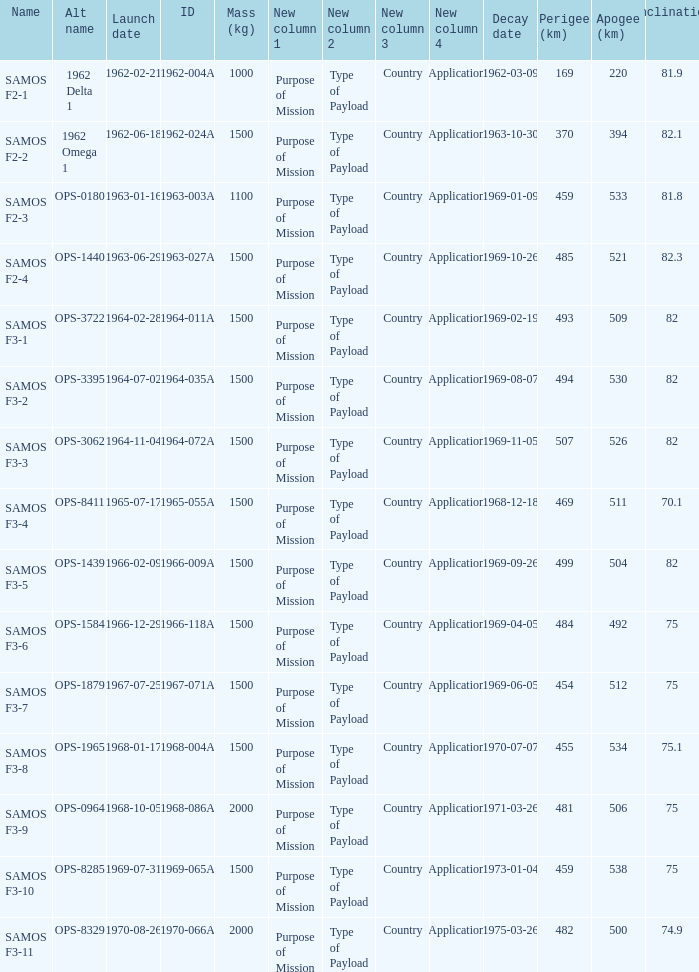What was the maximum perigee on 1969-01-09? 459.0. 